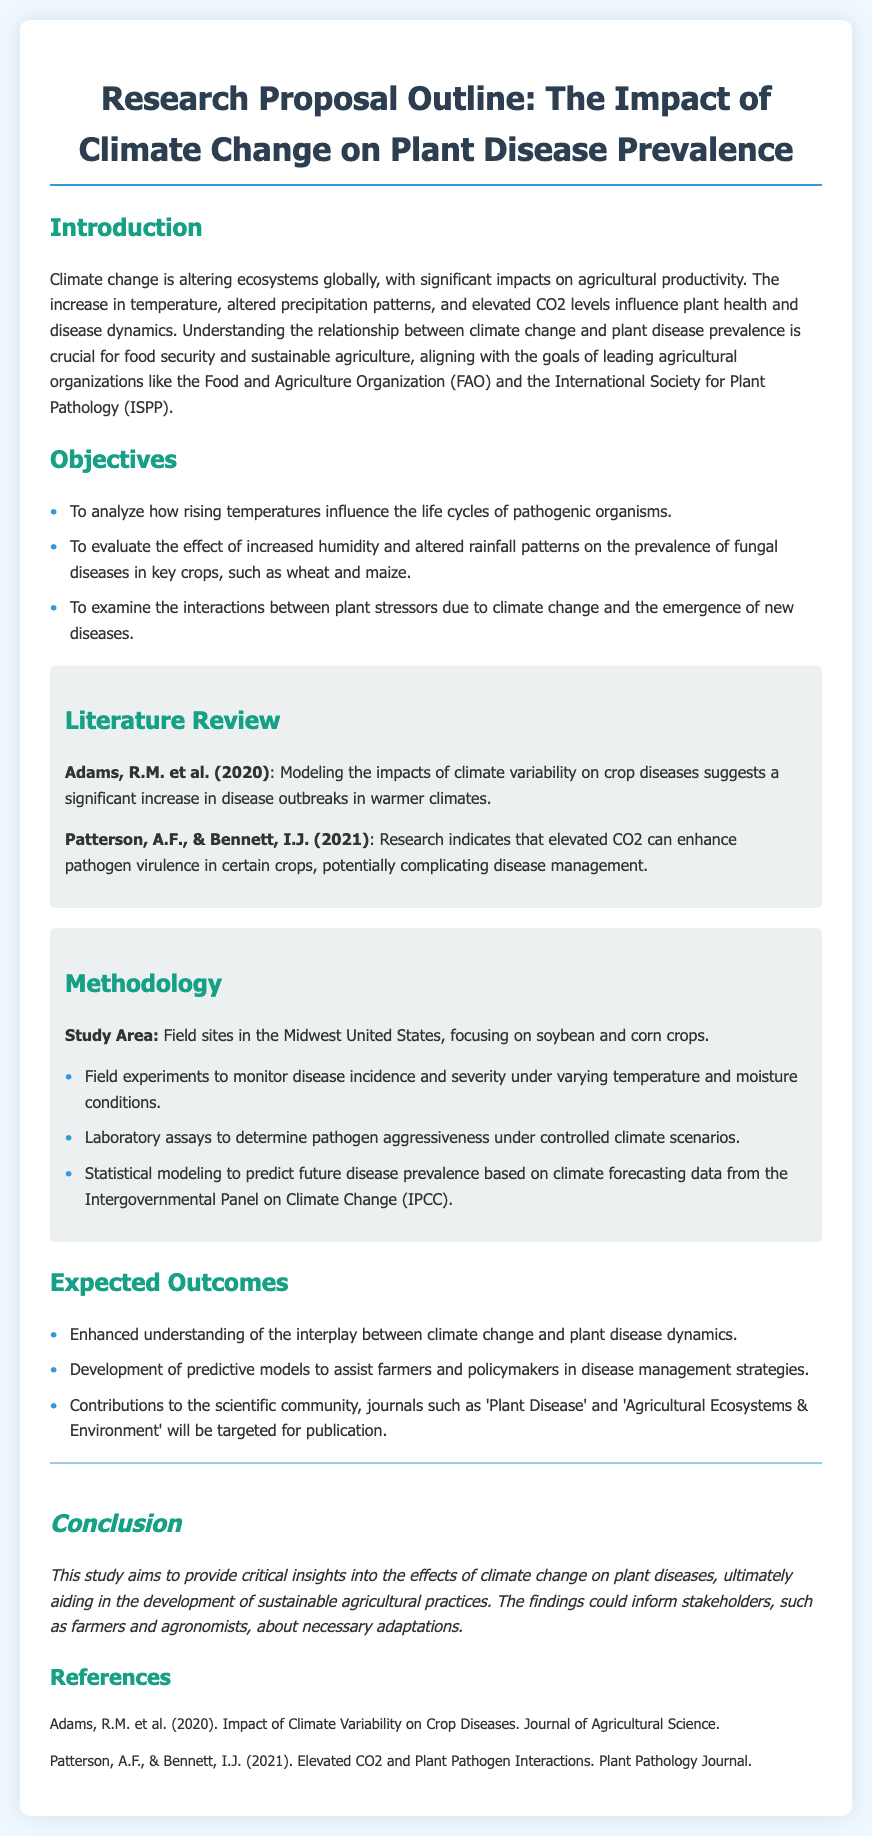What is the title of the research proposal? The title summarizing the focus of the study is found in the header section of the document.
Answer: Research Proposal Outline: The Impact of Climate Change on Plant Disease Prevalence What are the main crops studied in the methodology? The methodology section specifies the crop types to be investigated within the study area.
Answer: soybean and corn Which organization does the proposal align with regarding food security? The introduction mentions leading agricultural organizations that the research aligns with.
Answer: Food and Agriculture Organization (FAO) How many objectives are outlined in the proposal? The objectives section lists specific aims of the research. The number of points listed indicates the total objectives.
Answer: Three Who are the authors of the literature mentioned in the review? The literature review cites authors and their publications related to the study.
Answer: Adams, R.M. et al. and Patterson, A.F., & Bennett, I.J What type of experiments will be conducted in the methodology? The methodology outlines different types of research experiments planned for the study.
Answer: Field experiments What is one of the expected outcomes of the research? The expected outcomes section provides insights into the benefits of the study.
Answer: Enhanced understanding of the interplay between climate change and plant disease dynamics What journal is targeted for publication according to the expected outcomes? The expected outcomes specify particular academic journals aimed for submission of findings.
Answer: Plant Disease What year did the study by Adams et al. take place? The literature review section lists publication dates for the referenced studies.
Answer: 2020 